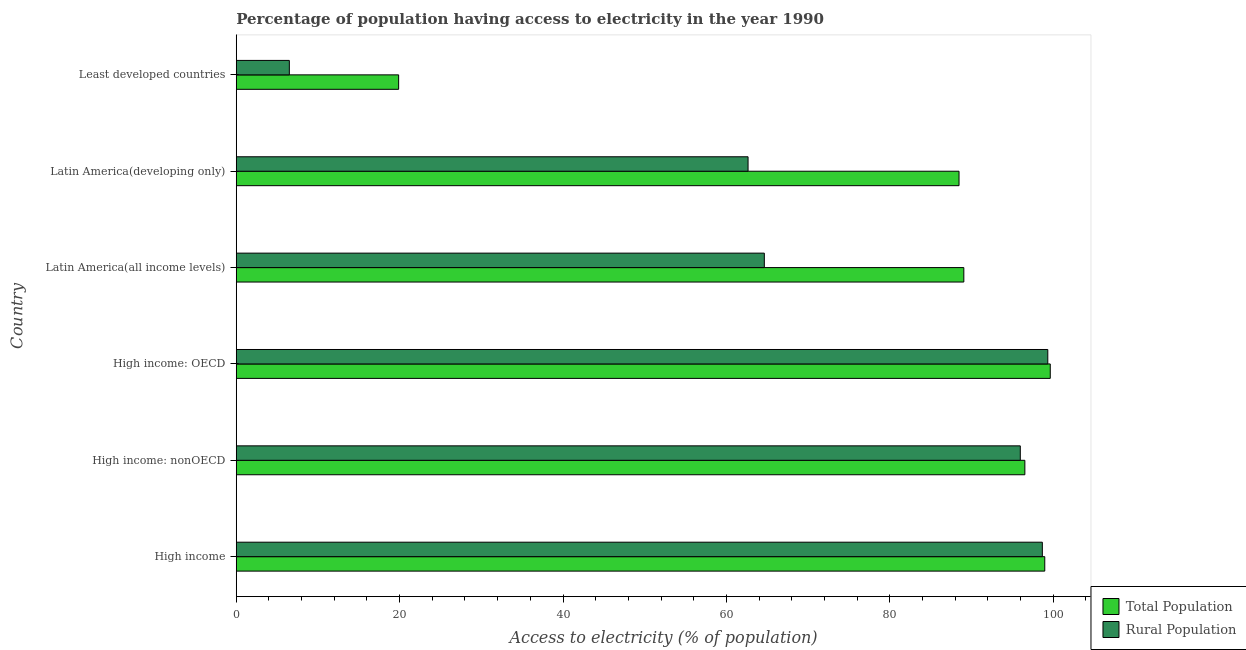How many different coloured bars are there?
Ensure brevity in your answer.  2. What is the label of the 1st group of bars from the top?
Ensure brevity in your answer.  Least developed countries. In how many cases, is the number of bars for a given country not equal to the number of legend labels?
Keep it short and to the point. 0. What is the percentage of rural population having access to electricity in Latin America(developing only)?
Your answer should be compact. 62.65. Across all countries, what is the maximum percentage of rural population having access to electricity?
Your answer should be very brief. 99.34. Across all countries, what is the minimum percentage of population having access to electricity?
Provide a succinct answer. 19.88. In which country was the percentage of rural population having access to electricity maximum?
Ensure brevity in your answer.  High income: OECD. In which country was the percentage of rural population having access to electricity minimum?
Provide a succinct answer. Least developed countries. What is the total percentage of rural population having access to electricity in the graph?
Your response must be concise. 427.79. What is the difference between the percentage of rural population having access to electricity in Latin America(developing only) and that in Least developed countries?
Keep it short and to the point. 56.15. What is the difference between the percentage of rural population having access to electricity in High income and the percentage of population having access to electricity in High income: OECD?
Your response must be concise. -0.97. What is the average percentage of population having access to electricity per country?
Ensure brevity in your answer.  82.09. What is the difference between the percentage of rural population having access to electricity and percentage of population having access to electricity in Latin America(developing only)?
Ensure brevity in your answer.  -25.82. In how many countries, is the percentage of rural population having access to electricity greater than 80 %?
Keep it short and to the point. 3. What is the ratio of the percentage of population having access to electricity in High income: nonOECD to that in Latin America(developing only)?
Offer a very short reply. 1.09. Is the difference between the percentage of rural population having access to electricity in High income: OECD and High income: nonOECD greater than the difference between the percentage of population having access to electricity in High income: OECD and High income: nonOECD?
Your answer should be very brief. Yes. What is the difference between the highest and the second highest percentage of population having access to electricity?
Provide a short and direct response. 0.67. What is the difference between the highest and the lowest percentage of population having access to electricity?
Give a very brief answer. 79.77. What does the 2nd bar from the top in Least developed countries represents?
Offer a very short reply. Total Population. What does the 2nd bar from the bottom in High income: nonOECD represents?
Your answer should be compact. Rural Population. How many bars are there?
Offer a very short reply. 12. Are the values on the major ticks of X-axis written in scientific E-notation?
Provide a succinct answer. No. Where does the legend appear in the graph?
Your answer should be compact. Bottom right. How many legend labels are there?
Your response must be concise. 2. What is the title of the graph?
Your response must be concise. Percentage of population having access to electricity in the year 1990. What is the label or title of the X-axis?
Make the answer very short. Access to electricity (% of population). What is the Access to electricity (% of population) of Total Population in High income?
Provide a short and direct response. 98.97. What is the Access to electricity (% of population) of Rural Population in High income?
Offer a terse response. 98.67. What is the Access to electricity (% of population) in Total Population in High income: nonOECD?
Provide a succinct answer. 96.53. What is the Access to electricity (% of population) of Rural Population in High income: nonOECD?
Offer a very short reply. 95.98. What is the Access to electricity (% of population) of Total Population in High income: OECD?
Ensure brevity in your answer.  99.64. What is the Access to electricity (% of population) in Rural Population in High income: OECD?
Make the answer very short. 99.34. What is the Access to electricity (% of population) of Total Population in Latin America(all income levels)?
Give a very brief answer. 89.06. What is the Access to electricity (% of population) in Rural Population in Latin America(all income levels)?
Offer a terse response. 64.64. What is the Access to electricity (% of population) of Total Population in Latin America(developing only)?
Make the answer very short. 88.48. What is the Access to electricity (% of population) in Rural Population in Latin America(developing only)?
Provide a short and direct response. 62.65. What is the Access to electricity (% of population) in Total Population in Least developed countries?
Keep it short and to the point. 19.88. What is the Access to electricity (% of population) in Rural Population in Least developed countries?
Offer a very short reply. 6.5. Across all countries, what is the maximum Access to electricity (% of population) in Total Population?
Your response must be concise. 99.64. Across all countries, what is the maximum Access to electricity (% of population) of Rural Population?
Provide a short and direct response. 99.34. Across all countries, what is the minimum Access to electricity (% of population) in Total Population?
Your answer should be compact. 19.88. Across all countries, what is the minimum Access to electricity (% of population) of Rural Population?
Offer a terse response. 6.5. What is the total Access to electricity (% of population) in Total Population in the graph?
Offer a terse response. 492.57. What is the total Access to electricity (% of population) of Rural Population in the graph?
Provide a succinct answer. 427.79. What is the difference between the Access to electricity (% of population) in Total Population in High income and that in High income: nonOECD?
Give a very brief answer. 2.44. What is the difference between the Access to electricity (% of population) in Rural Population in High income and that in High income: nonOECD?
Keep it short and to the point. 2.7. What is the difference between the Access to electricity (% of population) in Total Population in High income and that in High income: OECD?
Provide a short and direct response. -0.67. What is the difference between the Access to electricity (% of population) of Rural Population in High income and that in High income: OECD?
Make the answer very short. -0.67. What is the difference between the Access to electricity (% of population) of Total Population in High income and that in Latin America(all income levels)?
Give a very brief answer. 9.91. What is the difference between the Access to electricity (% of population) in Rural Population in High income and that in Latin America(all income levels)?
Give a very brief answer. 34.03. What is the difference between the Access to electricity (% of population) in Total Population in High income and that in Latin America(developing only)?
Offer a very short reply. 10.49. What is the difference between the Access to electricity (% of population) in Rural Population in High income and that in Latin America(developing only)?
Offer a very short reply. 36.02. What is the difference between the Access to electricity (% of population) in Total Population in High income and that in Least developed countries?
Make the answer very short. 79.09. What is the difference between the Access to electricity (% of population) of Rural Population in High income and that in Least developed countries?
Your response must be concise. 92.18. What is the difference between the Access to electricity (% of population) of Total Population in High income: nonOECD and that in High income: OECD?
Provide a short and direct response. -3.11. What is the difference between the Access to electricity (% of population) of Rural Population in High income: nonOECD and that in High income: OECD?
Offer a terse response. -3.37. What is the difference between the Access to electricity (% of population) in Total Population in High income: nonOECD and that in Latin America(all income levels)?
Give a very brief answer. 7.47. What is the difference between the Access to electricity (% of population) of Rural Population in High income: nonOECD and that in Latin America(all income levels)?
Offer a terse response. 31.33. What is the difference between the Access to electricity (% of population) of Total Population in High income: nonOECD and that in Latin America(developing only)?
Offer a very short reply. 8.06. What is the difference between the Access to electricity (% of population) in Rural Population in High income: nonOECD and that in Latin America(developing only)?
Provide a short and direct response. 33.33. What is the difference between the Access to electricity (% of population) of Total Population in High income: nonOECD and that in Least developed countries?
Ensure brevity in your answer.  76.66. What is the difference between the Access to electricity (% of population) in Rural Population in High income: nonOECD and that in Least developed countries?
Provide a succinct answer. 89.48. What is the difference between the Access to electricity (% of population) of Total Population in High income: OECD and that in Latin America(all income levels)?
Give a very brief answer. 10.58. What is the difference between the Access to electricity (% of population) in Rural Population in High income: OECD and that in Latin America(all income levels)?
Your answer should be compact. 34.7. What is the difference between the Access to electricity (% of population) in Total Population in High income: OECD and that in Latin America(developing only)?
Offer a terse response. 11.17. What is the difference between the Access to electricity (% of population) of Rural Population in High income: OECD and that in Latin America(developing only)?
Give a very brief answer. 36.69. What is the difference between the Access to electricity (% of population) of Total Population in High income: OECD and that in Least developed countries?
Your answer should be very brief. 79.77. What is the difference between the Access to electricity (% of population) in Rural Population in High income: OECD and that in Least developed countries?
Keep it short and to the point. 92.84. What is the difference between the Access to electricity (% of population) of Total Population in Latin America(all income levels) and that in Latin America(developing only)?
Your answer should be compact. 0.59. What is the difference between the Access to electricity (% of population) in Rural Population in Latin America(all income levels) and that in Latin America(developing only)?
Offer a terse response. 1.99. What is the difference between the Access to electricity (% of population) of Total Population in Latin America(all income levels) and that in Least developed countries?
Ensure brevity in your answer.  69.19. What is the difference between the Access to electricity (% of population) in Rural Population in Latin America(all income levels) and that in Least developed countries?
Offer a very short reply. 58.14. What is the difference between the Access to electricity (% of population) in Total Population in Latin America(developing only) and that in Least developed countries?
Offer a terse response. 68.6. What is the difference between the Access to electricity (% of population) in Rural Population in Latin America(developing only) and that in Least developed countries?
Offer a terse response. 56.15. What is the difference between the Access to electricity (% of population) in Total Population in High income and the Access to electricity (% of population) in Rural Population in High income: nonOECD?
Ensure brevity in your answer.  2.99. What is the difference between the Access to electricity (% of population) in Total Population in High income and the Access to electricity (% of population) in Rural Population in High income: OECD?
Offer a very short reply. -0.37. What is the difference between the Access to electricity (% of population) of Total Population in High income and the Access to electricity (% of population) of Rural Population in Latin America(all income levels)?
Keep it short and to the point. 34.33. What is the difference between the Access to electricity (% of population) in Total Population in High income and the Access to electricity (% of population) in Rural Population in Latin America(developing only)?
Keep it short and to the point. 36.32. What is the difference between the Access to electricity (% of population) in Total Population in High income and the Access to electricity (% of population) in Rural Population in Least developed countries?
Ensure brevity in your answer.  92.47. What is the difference between the Access to electricity (% of population) of Total Population in High income: nonOECD and the Access to electricity (% of population) of Rural Population in High income: OECD?
Provide a short and direct response. -2.81. What is the difference between the Access to electricity (% of population) in Total Population in High income: nonOECD and the Access to electricity (% of population) in Rural Population in Latin America(all income levels)?
Offer a very short reply. 31.89. What is the difference between the Access to electricity (% of population) of Total Population in High income: nonOECD and the Access to electricity (% of population) of Rural Population in Latin America(developing only)?
Make the answer very short. 33.88. What is the difference between the Access to electricity (% of population) in Total Population in High income: nonOECD and the Access to electricity (% of population) in Rural Population in Least developed countries?
Ensure brevity in your answer.  90.04. What is the difference between the Access to electricity (% of population) of Total Population in High income: OECD and the Access to electricity (% of population) of Rural Population in Latin America(all income levels)?
Give a very brief answer. 35. What is the difference between the Access to electricity (% of population) of Total Population in High income: OECD and the Access to electricity (% of population) of Rural Population in Latin America(developing only)?
Give a very brief answer. 36.99. What is the difference between the Access to electricity (% of population) of Total Population in High income: OECD and the Access to electricity (% of population) of Rural Population in Least developed countries?
Your response must be concise. 93.15. What is the difference between the Access to electricity (% of population) of Total Population in Latin America(all income levels) and the Access to electricity (% of population) of Rural Population in Latin America(developing only)?
Provide a succinct answer. 26.41. What is the difference between the Access to electricity (% of population) of Total Population in Latin America(all income levels) and the Access to electricity (% of population) of Rural Population in Least developed countries?
Ensure brevity in your answer.  82.57. What is the difference between the Access to electricity (% of population) in Total Population in Latin America(developing only) and the Access to electricity (% of population) in Rural Population in Least developed countries?
Keep it short and to the point. 81.98. What is the average Access to electricity (% of population) of Total Population per country?
Offer a very short reply. 82.09. What is the average Access to electricity (% of population) of Rural Population per country?
Offer a very short reply. 71.3. What is the difference between the Access to electricity (% of population) in Total Population and Access to electricity (% of population) in Rural Population in High income?
Offer a terse response. 0.3. What is the difference between the Access to electricity (% of population) of Total Population and Access to electricity (% of population) of Rural Population in High income: nonOECD?
Keep it short and to the point. 0.56. What is the difference between the Access to electricity (% of population) of Total Population and Access to electricity (% of population) of Rural Population in High income: OECD?
Provide a succinct answer. 0.3. What is the difference between the Access to electricity (% of population) of Total Population and Access to electricity (% of population) of Rural Population in Latin America(all income levels)?
Provide a short and direct response. 24.42. What is the difference between the Access to electricity (% of population) in Total Population and Access to electricity (% of population) in Rural Population in Latin America(developing only)?
Your answer should be very brief. 25.82. What is the difference between the Access to electricity (% of population) in Total Population and Access to electricity (% of population) in Rural Population in Least developed countries?
Provide a succinct answer. 13.38. What is the ratio of the Access to electricity (% of population) in Total Population in High income to that in High income: nonOECD?
Give a very brief answer. 1.03. What is the ratio of the Access to electricity (% of population) in Rural Population in High income to that in High income: nonOECD?
Give a very brief answer. 1.03. What is the ratio of the Access to electricity (% of population) in Rural Population in High income to that in High income: OECD?
Offer a very short reply. 0.99. What is the ratio of the Access to electricity (% of population) in Total Population in High income to that in Latin America(all income levels)?
Your response must be concise. 1.11. What is the ratio of the Access to electricity (% of population) in Rural Population in High income to that in Latin America(all income levels)?
Provide a succinct answer. 1.53. What is the ratio of the Access to electricity (% of population) in Total Population in High income to that in Latin America(developing only)?
Ensure brevity in your answer.  1.12. What is the ratio of the Access to electricity (% of population) in Rural Population in High income to that in Latin America(developing only)?
Your response must be concise. 1.57. What is the ratio of the Access to electricity (% of population) of Total Population in High income to that in Least developed countries?
Provide a succinct answer. 4.98. What is the ratio of the Access to electricity (% of population) in Rural Population in High income to that in Least developed countries?
Provide a succinct answer. 15.18. What is the ratio of the Access to electricity (% of population) of Total Population in High income: nonOECD to that in High income: OECD?
Make the answer very short. 0.97. What is the ratio of the Access to electricity (% of population) of Rural Population in High income: nonOECD to that in High income: OECD?
Give a very brief answer. 0.97. What is the ratio of the Access to electricity (% of population) of Total Population in High income: nonOECD to that in Latin America(all income levels)?
Keep it short and to the point. 1.08. What is the ratio of the Access to electricity (% of population) of Rural Population in High income: nonOECD to that in Latin America(all income levels)?
Offer a very short reply. 1.48. What is the ratio of the Access to electricity (% of population) in Total Population in High income: nonOECD to that in Latin America(developing only)?
Give a very brief answer. 1.09. What is the ratio of the Access to electricity (% of population) in Rural Population in High income: nonOECD to that in Latin America(developing only)?
Your answer should be very brief. 1.53. What is the ratio of the Access to electricity (% of population) of Total Population in High income: nonOECD to that in Least developed countries?
Offer a very short reply. 4.86. What is the ratio of the Access to electricity (% of population) in Rural Population in High income: nonOECD to that in Least developed countries?
Your answer should be very brief. 14.77. What is the ratio of the Access to electricity (% of population) of Total Population in High income: OECD to that in Latin America(all income levels)?
Offer a very short reply. 1.12. What is the ratio of the Access to electricity (% of population) of Rural Population in High income: OECD to that in Latin America(all income levels)?
Your answer should be compact. 1.54. What is the ratio of the Access to electricity (% of population) of Total Population in High income: OECD to that in Latin America(developing only)?
Offer a very short reply. 1.13. What is the ratio of the Access to electricity (% of population) of Rural Population in High income: OECD to that in Latin America(developing only)?
Offer a very short reply. 1.59. What is the ratio of the Access to electricity (% of population) of Total Population in High income: OECD to that in Least developed countries?
Give a very brief answer. 5.01. What is the ratio of the Access to electricity (% of population) in Rural Population in High income: OECD to that in Least developed countries?
Ensure brevity in your answer.  15.29. What is the ratio of the Access to electricity (% of population) in Total Population in Latin America(all income levels) to that in Latin America(developing only)?
Your answer should be compact. 1.01. What is the ratio of the Access to electricity (% of population) of Rural Population in Latin America(all income levels) to that in Latin America(developing only)?
Your answer should be very brief. 1.03. What is the ratio of the Access to electricity (% of population) of Total Population in Latin America(all income levels) to that in Least developed countries?
Your answer should be very brief. 4.48. What is the ratio of the Access to electricity (% of population) in Rural Population in Latin America(all income levels) to that in Least developed countries?
Make the answer very short. 9.95. What is the ratio of the Access to electricity (% of population) of Total Population in Latin America(developing only) to that in Least developed countries?
Offer a very short reply. 4.45. What is the ratio of the Access to electricity (% of population) of Rural Population in Latin America(developing only) to that in Least developed countries?
Make the answer very short. 9.64. What is the difference between the highest and the second highest Access to electricity (% of population) of Total Population?
Provide a short and direct response. 0.67. What is the difference between the highest and the second highest Access to electricity (% of population) in Rural Population?
Your response must be concise. 0.67. What is the difference between the highest and the lowest Access to electricity (% of population) of Total Population?
Your response must be concise. 79.77. What is the difference between the highest and the lowest Access to electricity (% of population) of Rural Population?
Provide a succinct answer. 92.84. 